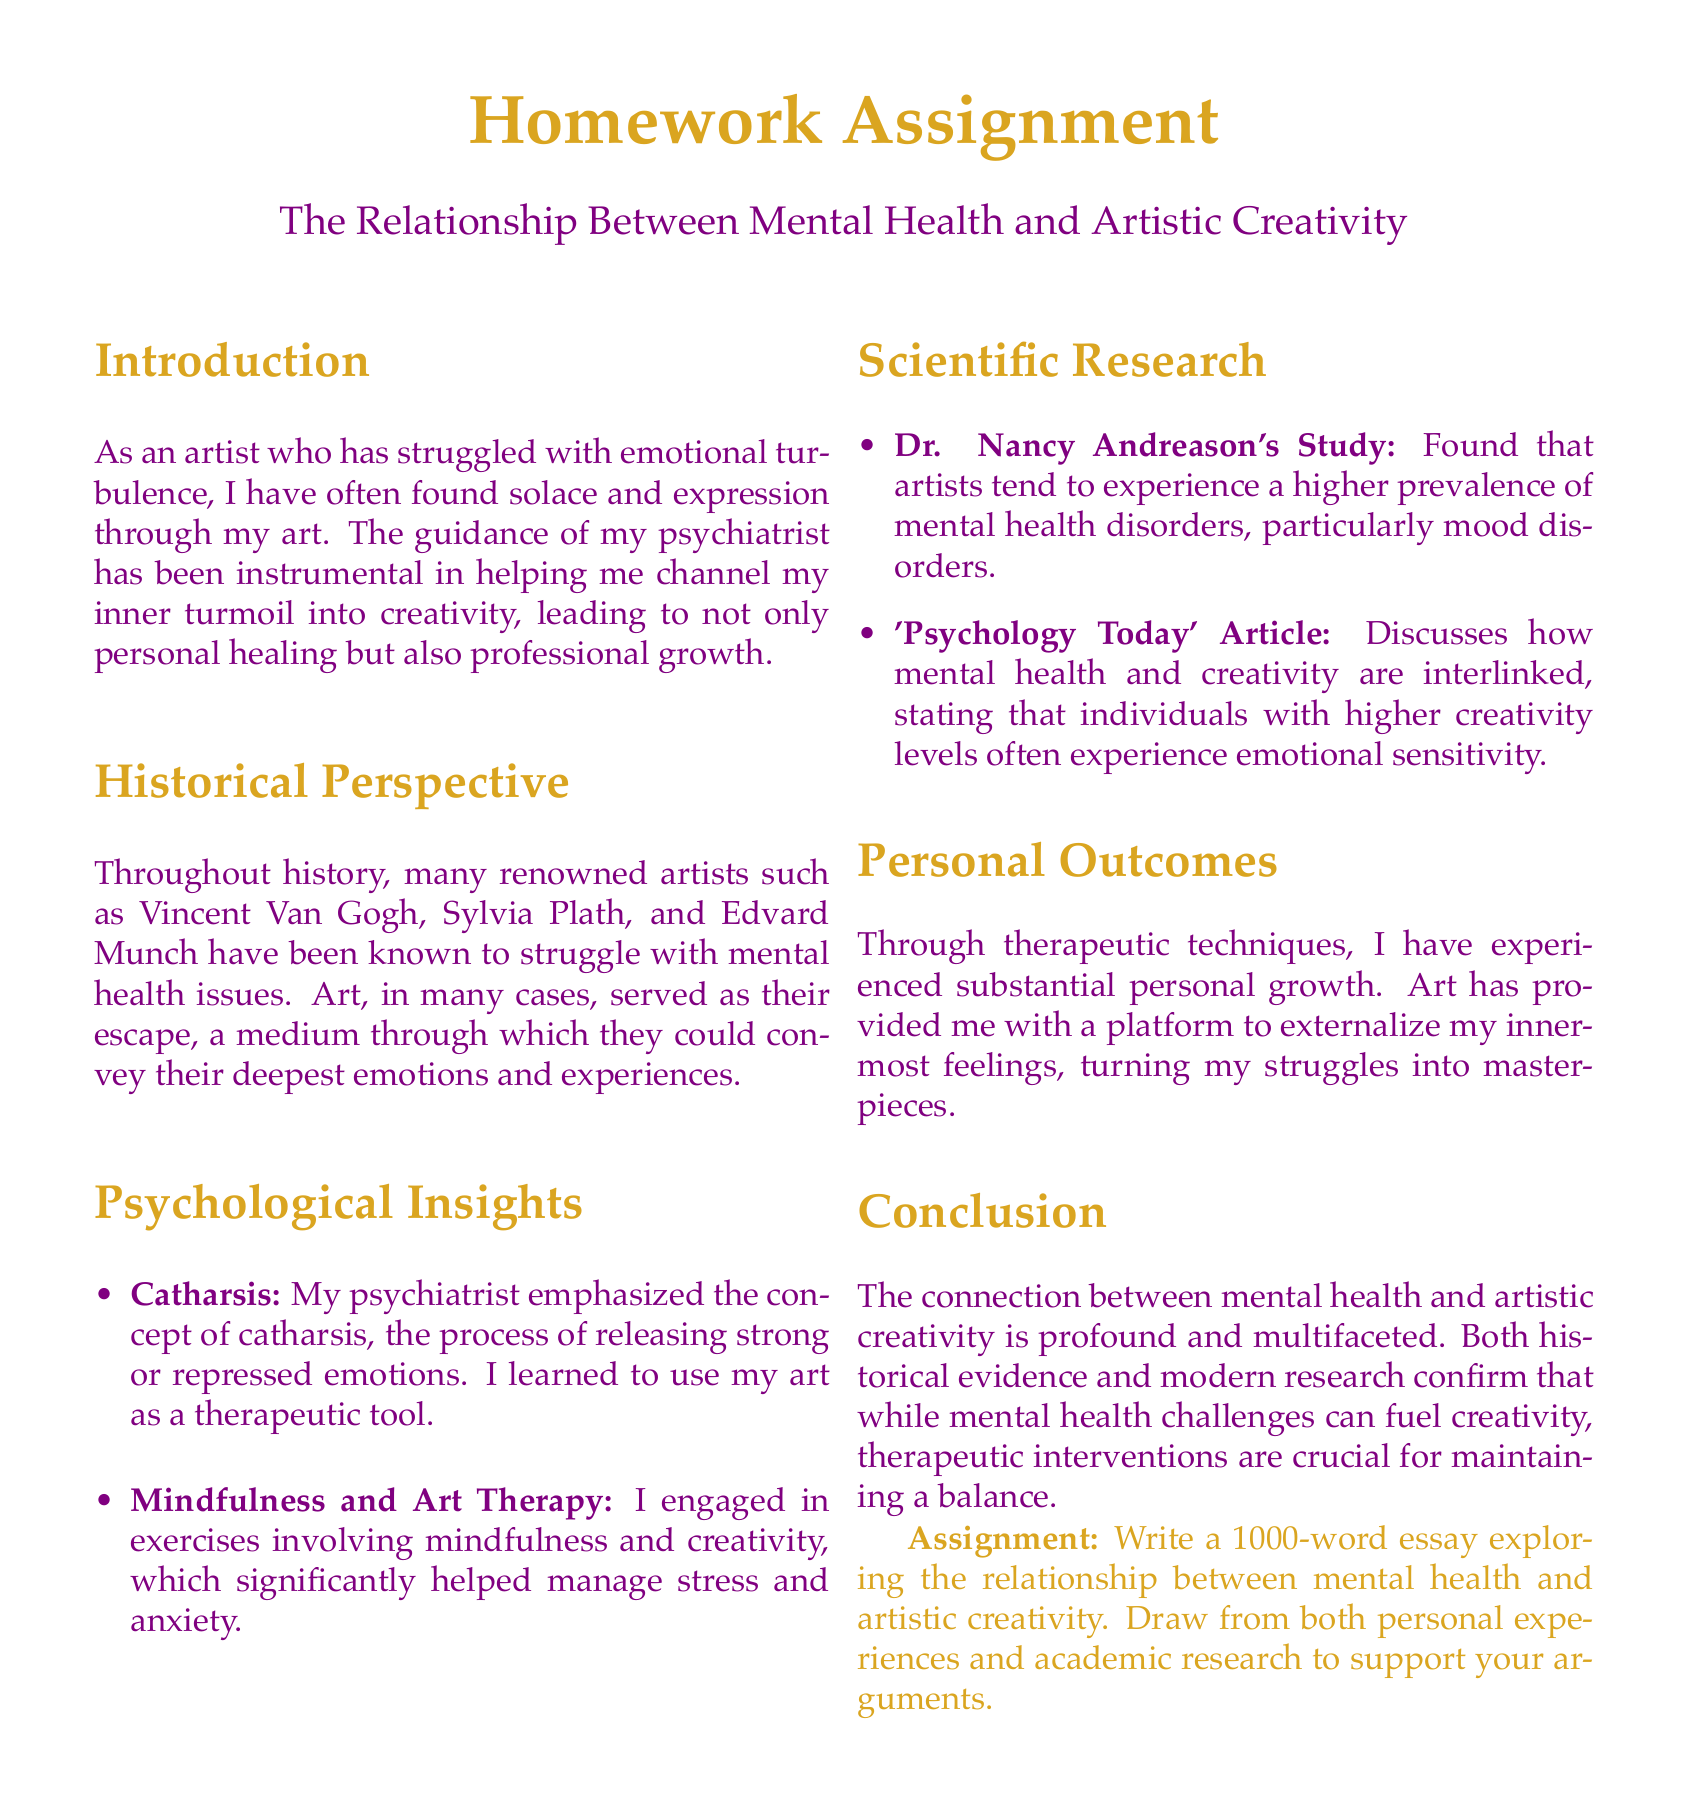What is the title of the homework assignment? The title is presented at the beginning of the document and indicates the paper's focus.
Answer: The Relationship Between Mental Health and Artistic Creativity Who are some historical artists mentioned in the document? The document lists artists known to have struggled with mental health challenges as examples.
Answer: Vincent Van Gogh, Sylvia Plath, Edvard Munch What is the main therapeutic concept emphasized by the psychiatrist? The document highlights a specific concept that aids in emotional release through art.
Answer: Catharsis What type of therapy exercises did the author engage in? The document specifies the kind of techniques that benefited the author's mental health and creativity.
Answer: Mindfulness and Art Therapy According to Dr. Nancy Andreason's study, what type of disorders do artists experience at a higher prevalence? The document summarizes the findings from a key psychological study regarding artists and their mental health.
Answer: Mood disorders What significant personal outcome did the author experience through art? The document describes a specific change that occurred in the author's life through their creative expression.
Answer: Substantial personal growth What is the required word count for the essay assignment? The assignment specifies the length requirements for the student's essay submission.
Answer: 1000 words What does the article from 'Psychology Today' discuss? The document indicates the focus of an article related to the themes of the paper.
Answer: Mental health and creativity interlink What is the overall conclusion about the relationship between mental health and artistic creativity? The conclusion summarizes the document's stance on the complexity of the relationship discussed.
Answer: Profound and multifaceted 